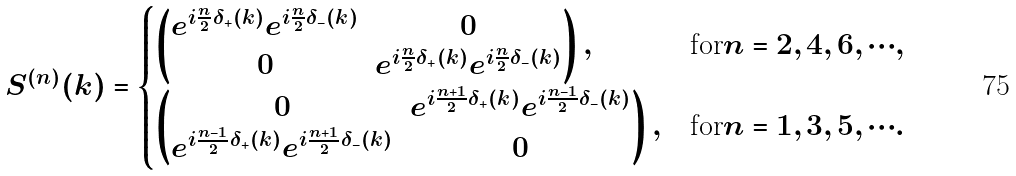Convert formula to latex. <formula><loc_0><loc_0><loc_500><loc_500>S ^ { ( n ) } ( k ) & = \begin{cases} \begin{pmatrix} e ^ { i \frac { n } { 2 } \delta _ { + } ( k ) } e ^ { i \frac { n } { 2 } \delta _ { - } ( k ) } & 0 \\ 0 & e ^ { i \frac { n } { 2 } \delta _ { + } ( k ) } e ^ { i \frac { n } { 2 } \delta _ { - } ( k ) } \end{pmatrix} , & \text {for} n = 2 , 4 , 6 , \cdots , \\ \begin{pmatrix} 0 & e ^ { i \frac { n + 1 } { 2 } \delta _ { + } ( k ) } e ^ { i \frac { n - 1 } { 2 } \delta _ { - } ( k ) } \\ e ^ { i \frac { n - 1 } { 2 } \delta _ { + } ( k ) } e ^ { i \frac { n + 1 } { 2 } \delta _ { - } ( k ) } & 0 \end{pmatrix} , & \text {for} n = 1 , 3 , 5 , \cdots . \end{cases}</formula> 